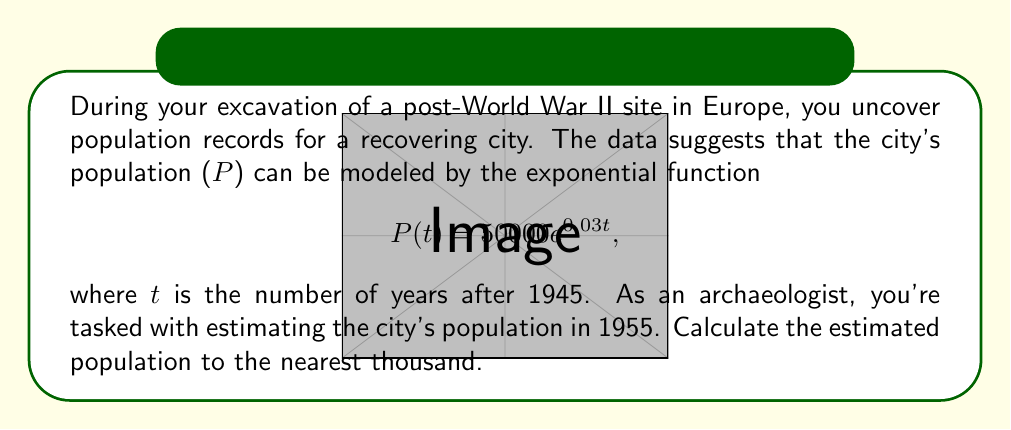Can you answer this question? To solve this problem, we'll follow these steps:

1) We're given the exponential function: $P(t) = 50000e^{0.03t}$
   Where:
   - P(t) is the population at time t
   - 50000 is the initial population (in 1945)
   - 0.03 is the growth rate
   - t is the number of years after 1945

2) We need to find P(10), as 1955 is 10 years after 1945.

3) Let's substitute t = 10 into our function:

   $P(10) = 50000e^{0.03(10)}$

4) Simplify the exponent:
   
   $P(10) = 50000e^{0.3}$

5) Calculate $e^{0.3}$ (you can use a calculator for this):
   
   $e^{0.3} \approx 1.34986$

6) Multiply:
   
   $P(10) = 50000 * 1.34986 \approx 67493$

7) Rounding to the nearest thousand:
   
   67493 rounds to 67000

Therefore, the estimated population in 1955 is approximately 67,000.
Answer: 67,000 